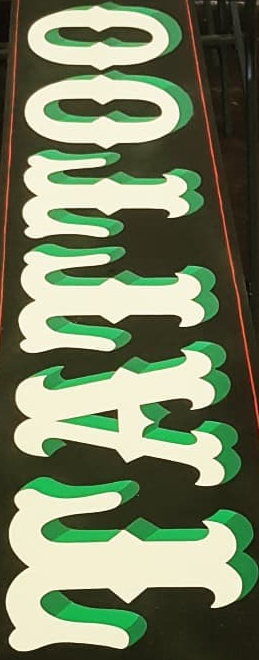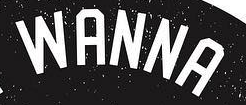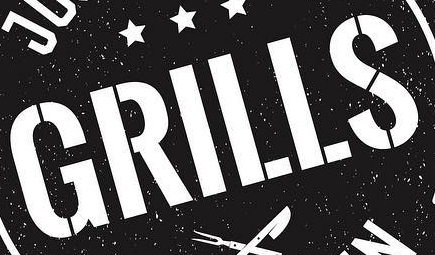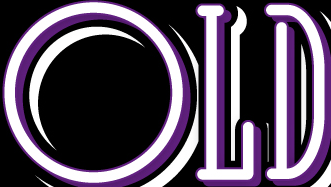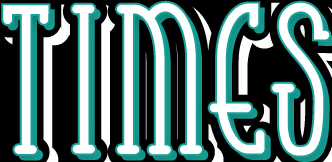Transcribe the words shown in these images in order, separated by a semicolon. TATTOO; WANNA; GRILLS; OLD; TIMES 